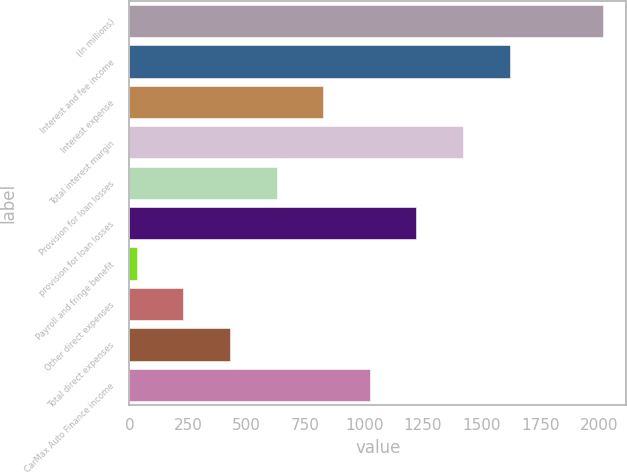Convert chart. <chart><loc_0><loc_0><loc_500><loc_500><bar_chart><fcel>(In millions)<fcel>Interest and fee income<fcel>Interest expense<fcel>Total interest margin<fcel>Provision for loan losses<fcel>provision for loan losses<fcel>Payroll and fringe benefit<fcel>Other direct expenses<fcel>Total direct expenses<fcel>CarMax Auto Finance income<nl><fcel>2017<fcel>1619.76<fcel>825.28<fcel>1421.14<fcel>626.66<fcel>1222.52<fcel>30.8<fcel>229.42<fcel>428.04<fcel>1023.9<nl></chart> 